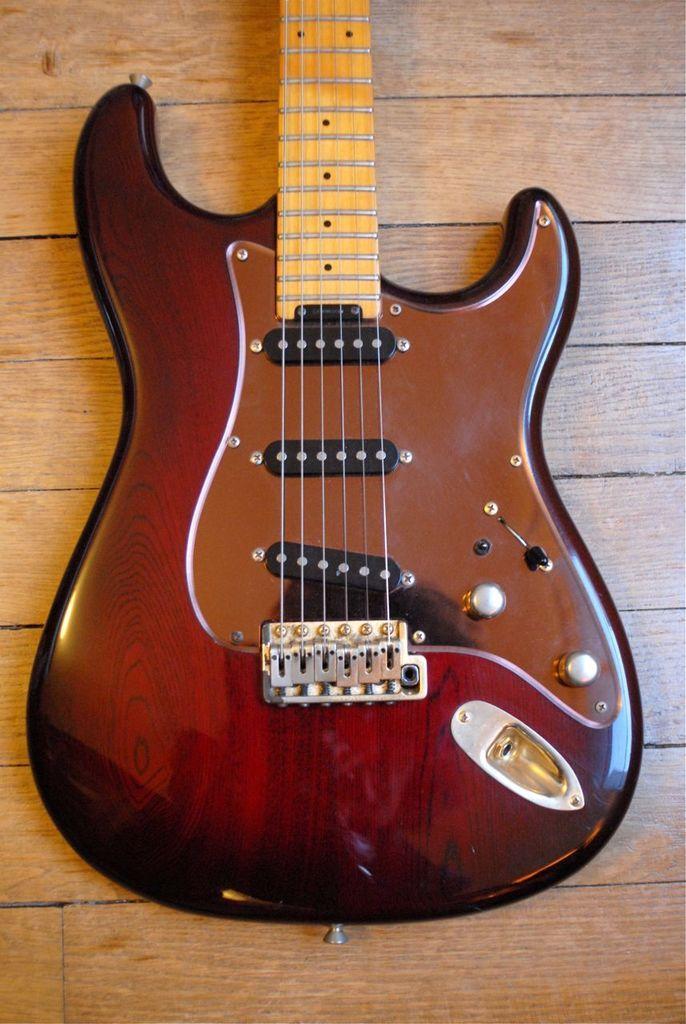Please provide a concise description of this image. This picture shows a guitar and six strings. The guitar is brown in color which is placed on the table. 